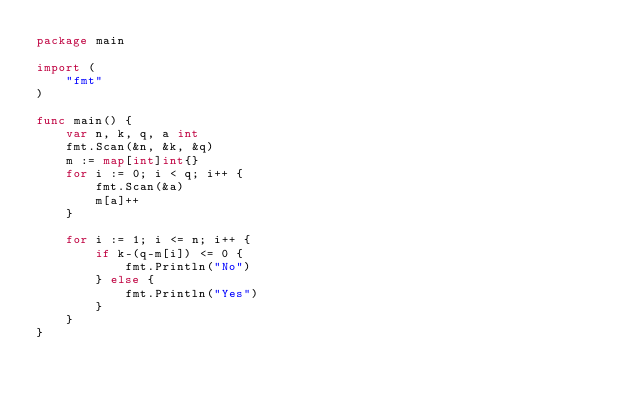<code> <loc_0><loc_0><loc_500><loc_500><_Go_>package main

import (
	"fmt"
)

func main() {
	var n, k, q, a int
	fmt.Scan(&n, &k, &q)
	m := map[int]int{}
	for i := 0; i < q; i++ {
		fmt.Scan(&a)
		m[a]++
	}

	for i := 1; i <= n; i++ {
		if k-(q-m[i]) <= 0 {
			fmt.Println("No")
		} else {
			fmt.Println("Yes")
		}
	}
}
</code> 